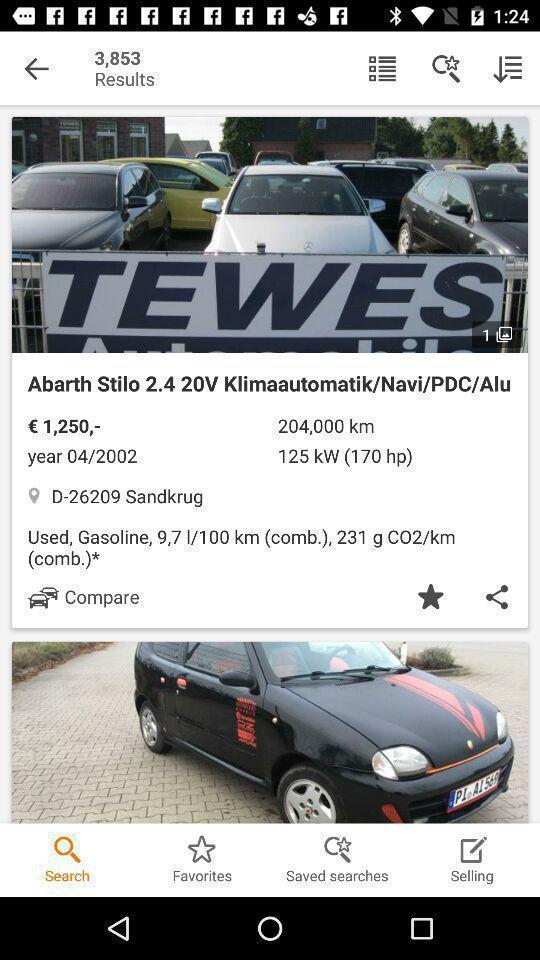Describe the key features of this screenshot. Screen displaying multiple vehicles information with price details. 